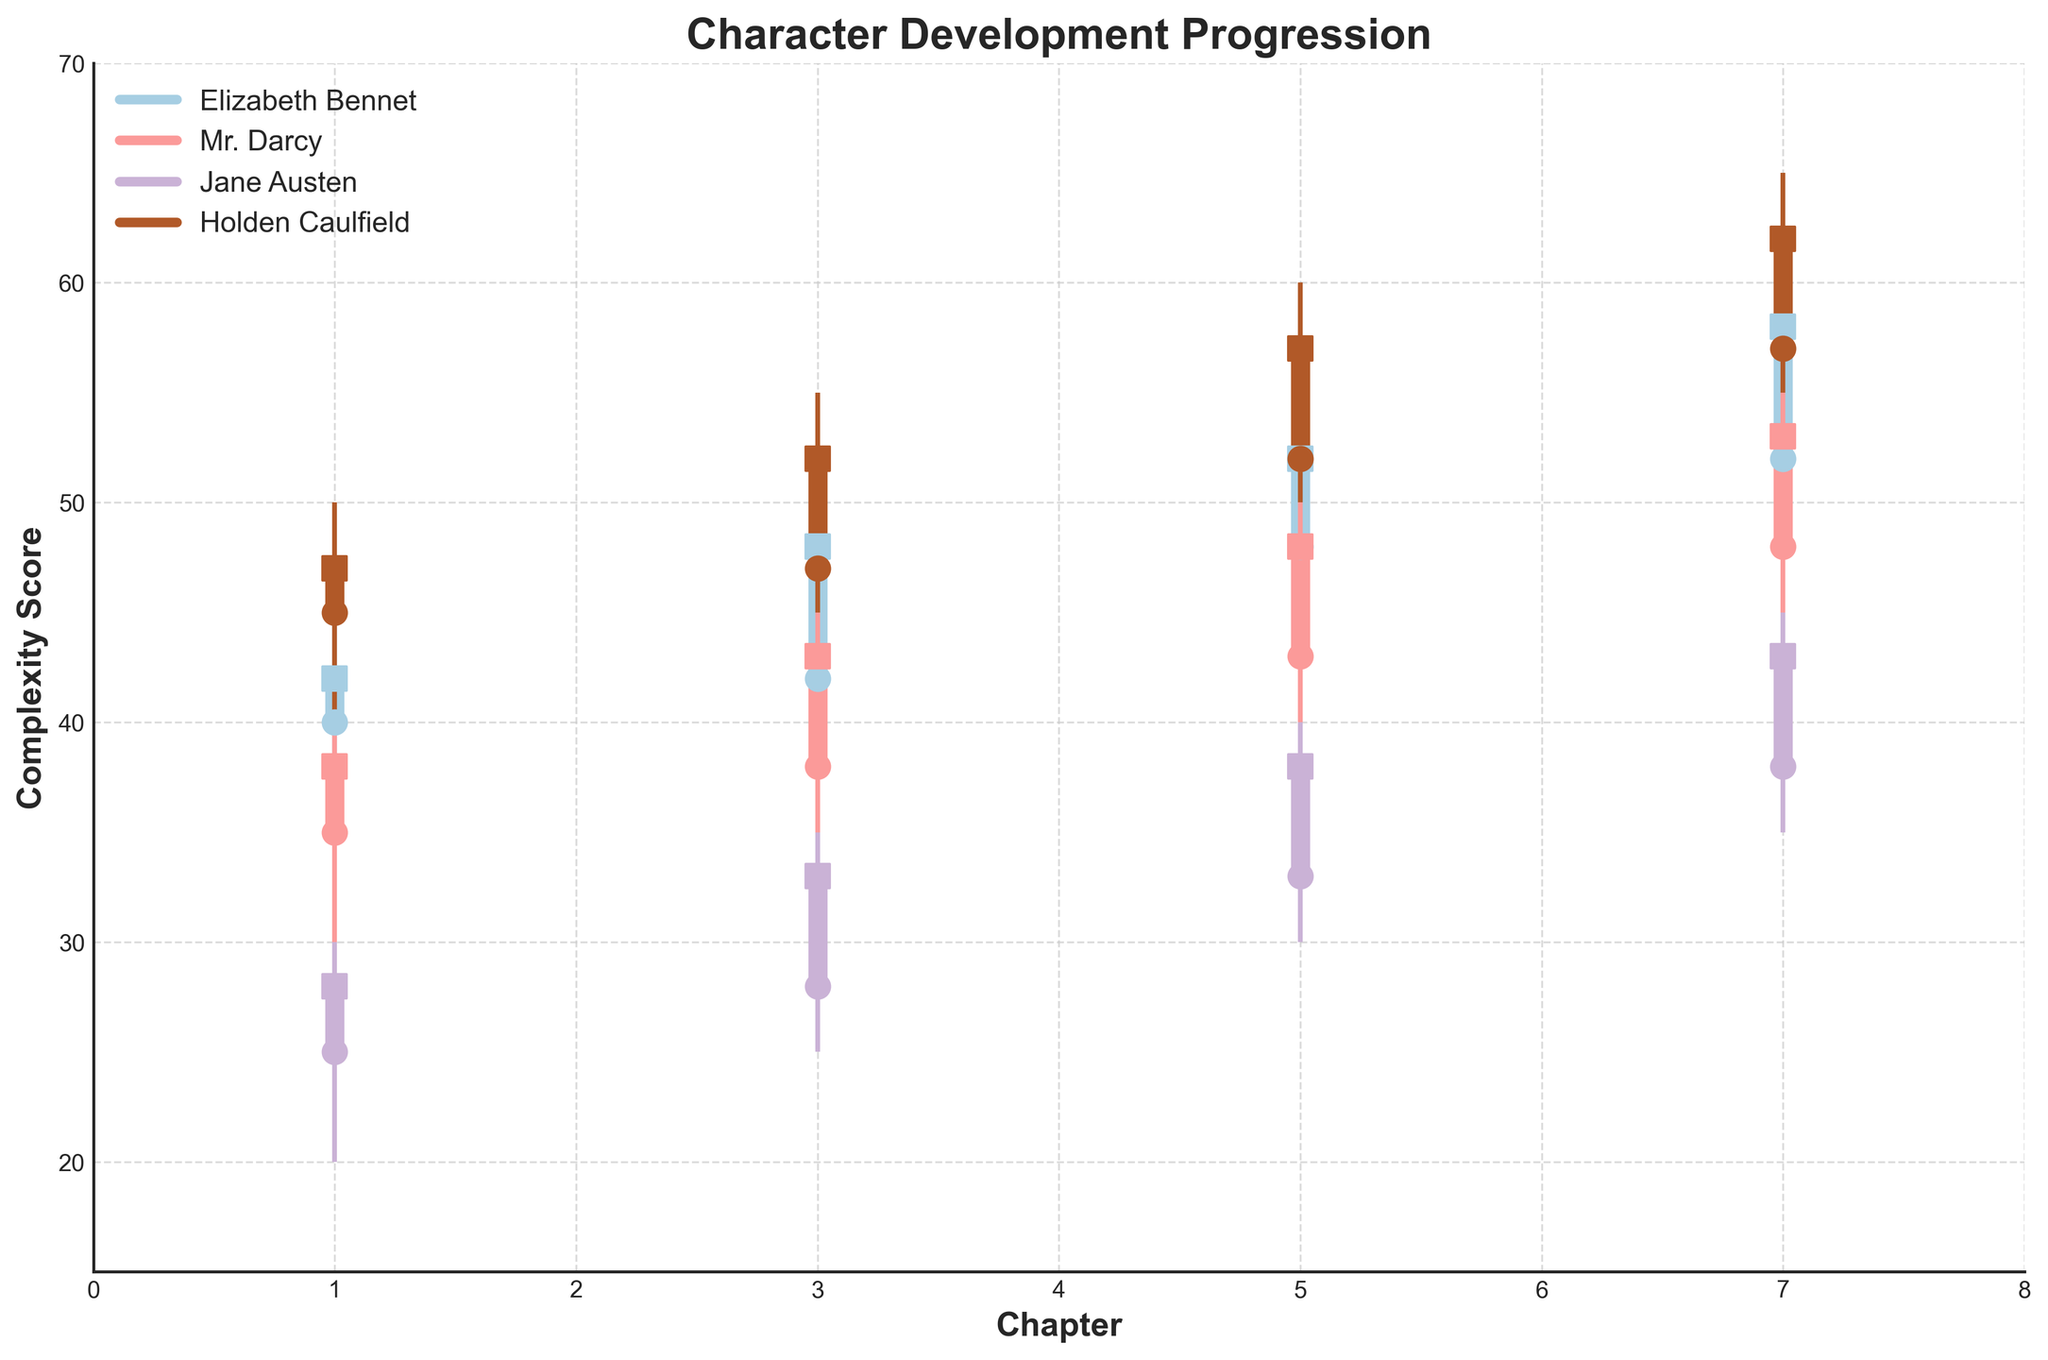What is the title of the figure? The title of the figure is displayed at the top of the plot. It reads "Character Development Progression."
Answer: Character Development Progression How many characters are tracked in the plot? The legend at the upper left corner of the plot lists the characters. There are four characters: Elizabeth Bennet, Mr. Darcy, Jane Austen, and Holden Caulfield.
Answer: Four What is the complexity score range for Mr. Darcy in Chapter 5? Look for the lines and markers corresponding to Mr. Darcy at Chapter 5. The data shows a range from 40 to 50.
Answer: 40 to 50 Which character has the highest complexity score in Chapter 7, and what is it? By identifying the highest point on the plot at Chapter 7, Holden Caulfield has the highest score of 65.
Answer: Holden Caulfield, 65 What is the difference between the closing complexity scores of Elizabeth Bennet and Jane Austen in Chapter 3? Refer to the closing scores for both characters in Chapter 3. Elizabeth Bennet closes at 48, and Jane Austen closes at 33. The difference is 48 - 33.
Answer: 15 Which character shows a consistent increase in complexity score across all chapters? Observe the trend lines for each character to detect a consistent increase. Both Elizabeth Bennet and Holden Caulfield show a consistent upward trend in their complexity scores.
Answer: Elizabeth Bennet, Holden Caulfield How does the opening complexity score of Mr. Darcy in Chapter 7 compare to his opening score in Chapter 1? Compare the data for Mr. Darcy's opening scores in Chapter 7 and Chapter 1. Chapter 7 is 48, and Chapter 1 is 35, indicating an increase.
Answer: It increased from 35 to 48 Which character has the largest difference between their open and close scores in Chapter 5? Calculate the differences for each character in Chapter 5: Elizabeth Bennet (48 - 52 = -4), Mr. Darcy (43 - 48 = -5), Jane Austen (33 - 38 = -5), Holden Caulfield (52 - 57 = -5). All have the same difference of -5, indicating equal differences.
Answer: Mr. Darcy, Jane Austen, Holden Caulfield Which character experiences the smallest range between their high and low scores in any single chapter? Analyze the ranges for each character in each chapter. Jane Austen in Chapter 1 has the smallest range with highs of 30 and lows of 20, which equals 10.
Answer: Jane Austen in Chapter 1 What is the average closing complexity score for Holden Caulfield over all chapters? Sum the closing scores for Holden Caulfield across all chapters (47 + 52 + 57 + 62) and divide by the number of chapters (4). The sum is 218, and the average is 218 / 4.
Answer: 54.5 